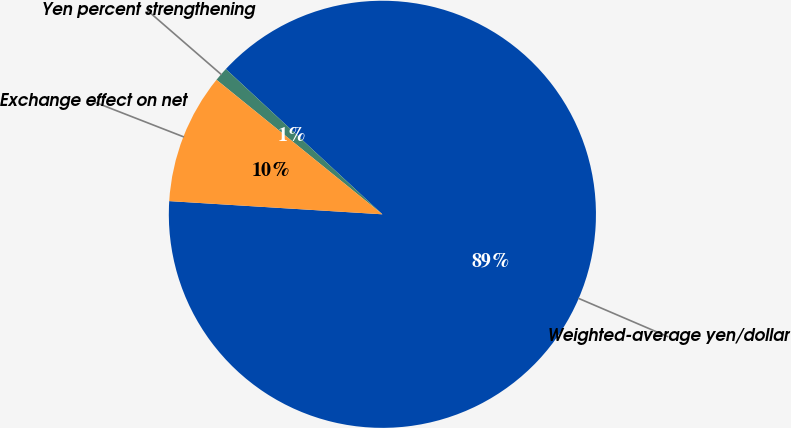Convert chart. <chart><loc_0><loc_0><loc_500><loc_500><pie_chart><fcel>Weighted-average yen/dollar<fcel>Yen percent strengthening<fcel>Exchange effect on net<nl><fcel>89.08%<fcel>1.06%<fcel>9.86%<nl></chart> 